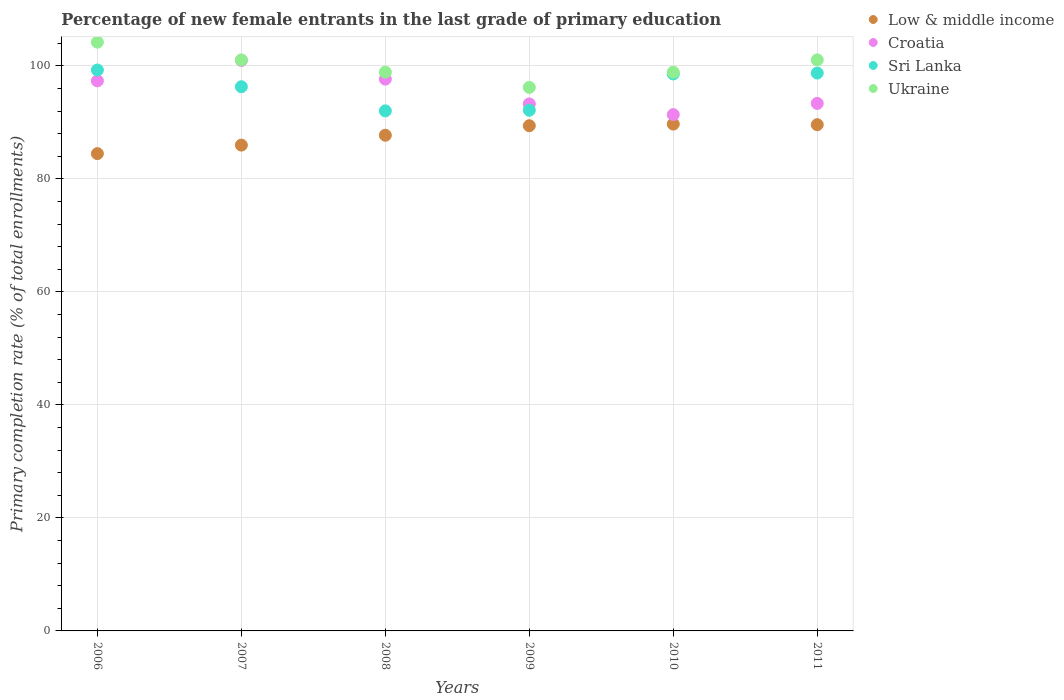Is the number of dotlines equal to the number of legend labels?
Offer a terse response. Yes. What is the percentage of new female entrants in Croatia in 2008?
Your response must be concise. 97.68. Across all years, what is the maximum percentage of new female entrants in Sri Lanka?
Keep it short and to the point. 99.28. Across all years, what is the minimum percentage of new female entrants in Sri Lanka?
Give a very brief answer. 92.05. In which year was the percentage of new female entrants in Ukraine maximum?
Your answer should be compact. 2006. What is the total percentage of new female entrants in Sri Lanka in the graph?
Your response must be concise. 577.14. What is the difference between the percentage of new female entrants in Sri Lanka in 2007 and that in 2008?
Give a very brief answer. 4.27. What is the difference between the percentage of new female entrants in Croatia in 2006 and the percentage of new female entrants in Sri Lanka in 2008?
Provide a short and direct response. 5.32. What is the average percentage of new female entrants in Sri Lanka per year?
Ensure brevity in your answer.  96.19. In the year 2011, what is the difference between the percentage of new female entrants in Ukraine and percentage of new female entrants in Croatia?
Provide a succinct answer. 7.7. What is the ratio of the percentage of new female entrants in Ukraine in 2009 to that in 2010?
Your answer should be compact. 0.97. Is the percentage of new female entrants in Sri Lanka in 2007 less than that in 2011?
Offer a terse response. Yes. What is the difference between the highest and the second highest percentage of new female entrants in Sri Lanka?
Your answer should be very brief. 0.54. What is the difference between the highest and the lowest percentage of new female entrants in Low & middle income?
Your answer should be very brief. 5.23. Is the sum of the percentage of new female entrants in Ukraine in 2009 and 2010 greater than the maximum percentage of new female entrants in Croatia across all years?
Your answer should be very brief. Yes. Is it the case that in every year, the sum of the percentage of new female entrants in Low & middle income and percentage of new female entrants in Ukraine  is greater than the percentage of new female entrants in Croatia?
Your response must be concise. Yes. Does the percentage of new female entrants in Croatia monotonically increase over the years?
Ensure brevity in your answer.  No. Is the percentage of new female entrants in Sri Lanka strictly greater than the percentage of new female entrants in Croatia over the years?
Offer a terse response. No. Is the percentage of new female entrants in Ukraine strictly less than the percentage of new female entrants in Sri Lanka over the years?
Make the answer very short. No. How many dotlines are there?
Give a very brief answer. 4. How many years are there in the graph?
Provide a short and direct response. 6. What is the difference between two consecutive major ticks on the Y-axis?
Provide a succinct answer. 20. Are the values on the major ticks of Y-axis written in scientific E-notation?
Give a very brief answer. No. Where does the legend appear in the graph?
Your answer should be compact. Top right. How many legend labels are there?
Your answer should be compact. 4. What is the title of the graph?
Provide a short and direct response. Percentage of new female entrants in the last grade of primary education. What is the label or title of the X-axis?
Your answer should be very brief. Years. What is the label or title of the Y-axis?
Your response must be concise. Primary completion rate (% of total enrollments). What is the Primary completion rate (% of total enrollments) in Low & middle income in 2006?
Offer a very short reply. 84.48. What is the Primary completion rate (% of total enrollments) of Croatia in 2006?
Offer a terse response. 97.37. What is the Primary completion rate (% of total enrollments) in Sri Lanka in 2006?
Provide a succinct answer. 99.28. What is the Primary completion rate (% of total enrollments) in Ukraine in 2006?
Provide a succinct answer. 104.21. What is the Primary completion rate (% of total enrollments) of Low & middle income in 2007?
Your answer should be compact. 85.99. What is the Primary completion rate (% of total enrollments) in Croatia in 2007?
Ensure brevity in your answer.  100.98. What is the Primary completion rate (% of total enrollments) of Sri Lanka in 2007?
Provide a succinct answer. 96.32. What is the Primary completion rate (% of total enrollments) of Ukraine in 2007?
Your answer should be compact. 101.06. What is the Primary completion rate (% of total enrollments) of Low & middle income in 2008?
Provide a succinct answer. 87.74. What is the Primary completion rate (% of total enrollments) of Croatia in 2008?
Keep it short and to the point. 97.68. What is the Primary completion rate (% of total enrollments) of Sri Lanka in 2008?
Ensure brevity in your answer.  92.05. What is the Primary completion rate (% of total enrollments) of Ukraine in 2008?
Your answer should be very brief. 98.91. What is the Primary completion rate (% of total enrollments) in Low & middle income in 2009?
Your response must be concise. 89.42. What is the Primary completion rate (% of total enrollments) of Croatia in 2009?
Offer a terse response. 93.27. What is the Primary completion rate (% of total enrollments) of Sri Lanka in 2009?
Your answer should be very brief. 92.16. What is the Primary completion rate (% of total enrollments) of Ukraine in 2009?
Give a very brief answer. 96.21. What is the Primary completion rate (% of total enrollments) of Low & middle income in 2010?
Give a very brief answer. 89.71. What is the Primary completion rate (% of total enrollments) in Croatia in 2010?
Give a very brief answer. 91.39. What is the Primary completion rate (% of total enrollments) in Sri Lanka in 2010?
Ensure brevity in your answer.  98.58. What is the Primary completion rate (% of total enrollments) in Ukraine in 2010?
Offer a very short reply. 98.9. What is the Primary completion rate (% of total enrollments) of Low & middle income in 2011?
Offer a terse response. 89.6. What is the Primary completion rate (% of total enrollments) of Croatia in 2011?
Offer a very short reply. 93.37. What is the Primary completion rate (% of total enrollments) in Sri Lanka in 2011?
Provide a succinct answer. 98.74. What is the Primary completion rate (% of total enrollments) in Ukraine in 2011?
Offer a terse response. 101.07. Across all years, what is the maximum Primary completion rate (% of total enrollments) in Low & middle income?
Give a very brief answer. 89.71. Across all years, what is the maximum Primary completion rate (% of total enrollments) in Croatia?
Your answer should be very brief. 100.98. Across all years, what is the maximum Primary completion rate (% of total enrollments) of Sri Lanka?
Make the answer very short. 99.28. Across all years, what is the maximum Primary completion rate (% of total enrollments) of Ukraine?
Provide a succinct answer. 104.21. Across all years, what is the minimum Primary completion rate (% of total enrollments) of Low & middle income?
Your response must be concise. 84.48. Across all years, what is the minimum Primary completion rate (% of total enrollments) in Croatia?
Make the answer very short. 91.39. Across all years, what is the minimum Primary completion rate (% of total enrollments) in Sri Lanka?
Your answer should be very brief. 92.05. Across all years, what is the minimum Primary completion rate (% of total enrollments) in Ukraine?
Offer a terse response. 96.21. What is the total Primary completion rate (% of total enrollments) of Low & middle income in the graph?
Your response must be concise. 526.94. What is the total Primary completion rate (% of total enrollments) of Croatia in the graph?
Give a very brief answer. 574.05. What is the total Primary completion rate (% of total enrollments) of Sri Lanka in the graph?
Offer a terse response. 577.14. What is the total Primary completion rate (% of total enrollments) in Ukraine in the graph?
Your response must be concise. 600.36. What is the difference between the Primary completion rate (% of total enrollments) in Low & middle income in 2006 and that in 2007?
Provide a succinct answer. -1.51. What is the difference between the Primary completion rate (% of total enrollments) of Croatia in 2006 and that in 2007?
Give a very brief answer. -3.61. What is the difference between the Primary completion rate (% of total enrollments) of Sri Lanka in 2006 and that in 2007?
Your answer should be very brief. 2.96. What is the difference between the Primary completion rate (% of total enrollments) in Ukraine in 2006 and that in 2007?
Give a very brief answer. 3.15. What is the difference between the Primary completion rate (% of total enrollments) of Low & middle income in 2006 and that in 2008?
Offer a terse response. -3.26. What is the difference between the Primary completion rate (% of total enrollments) of Croatia in 2006 and that in 2008?
Give a very brief answer. -0.31. What is the difference between the Primary completion rate (% of total enrollments) of Sri Lanka in 2006 and that in 2008?
Your answer should be compact. 7.23. What is the difference between the Primary completion rate (% of total enrollments) of Ukraine in 2006 and that in 2008?
Offer a terse response. 5.31. What is the difference between the Primary completion rate (% of total enrollments) in Low & middle income in 2006 and that in 2009?
Offer a terse response. -4.94. What is the difference between the Primary completion rate (% of total enrollments) of Croatia in 2006 and that in 2009?
Give a very brief answer. 4.09. What is the difference between the Primary completion rate (% of total enrollments) of Sri Lanka in 2006 and that in 2009?
Offer a very short reply. 7.12. What is the difference between the Primary completion rate (% of total enrollments) in Ukraine in 2006 and that in 2009?
Make the answer very short. 8.01. What is the difference between the Primary completion rate (% of total enrollments) in Low & middle income in 2006 and that in 2010?
Your answer should be very brief. -5.23. What is the difference between the Primary completion rate (% of total enrollments) of Croatia in 2006 and that in 2010?
Offer a very short reply. 5.98. What is the difference between the Primary completion rate (% of total enrollments) of Sri Lanka in 2006 and that in 2010?
Your answer should be compact. 0.7. What is the difference between the Primary completion rate (% of total enrollments) in Ukraine in 2006 and that in 2010?
Your answer should be compact. 5.32. What is the difference between the Primary completion rate (% of total enrollments) in Low & middle income in 2006 and that in 2011?
Your response must be concise. -5.12. What is the difference between the Primary completion rate (% of total enrollments) in Croatia in 2006 and that in 2011?
Your answer should be very brief. 4. What is the difference between the Primary completion rate (% of total enrollments) in Sri Lanka in 2006 and that in 2011?
Your response must be concise. 0.54. What is the difference between the Primary completion rate (% of total enrollments) of Ukraine in 2006 and that in 2011?
Keep it short and to the point. 3.14. What is the difference between the Primary completion rate (% of total enrollments) of Low & middle income in 2007 and that in 2008?
Your answer should be compact. -1.75. What is the difference between the Primary completion rate (% of total enrollments) of Croatia in 2007 and that in 2008?
Make the answer very short. 3.3. What is the difference between the Primary completion rate (% of total enrollments) in Sri Lanka in 2007 and that in 2008?
Keep it short and to the point. 4.27. What is the difference between the Primary completion rate (% of total enrollments) in Ukraine in 2007 and that in 2008?
Give a very brief answer. 2.16. What is the difference between the Primary completion rate (% of total enrollments) in Low & middle income in 2007 and that in 2009?
Ensure brevity in your answer.  -3.43. What is the difference between the Primary completion rate (% of total enrollments) of Croatia in 2007 and that in 2009?
Give a very brief answer. 7.7. What is the difference between the Primary completion rate (% of total enrollments) in Sri Lanka in 2007 and that in 2009?
Make the answer very short. 4.16. What is the difference between the Primary completion rate (% of total enrollments) in Ukraine in 2007 and that in 2009?
Your response must be concise. 4.86. What is the difference between the Primary completion rate (% of total enrollments) of Low & middle income in 2007 and that in 2010?
Offer a terse response. -3.72. What is the difference between the Primary completion rate (% of total enrollments) of Croatia in 2007 and that in 2010?
Offer a terse response. 9.59. What is the difference between the Primary completion rate (% of total enrollments) of Sri Lanka in 2007 and that in 2010?
Your response must be concise. -2.26. What is the difference between the Primary completion rate (% of total enrollments) of Ukraine in 2007 and that in 2010?
Offer a terse response. 2.17. What is the difference between the Primary completion rate (% of total enrollments) of Low & middle income in 2007 and that in 2011?
Your answer should be compact. -3.61. What is the difference between the Primary completion rate (% of total enrollments) of Croatia in 2007 and that in 2011?
Keep it short and to the point. 7.61. What is the difference between the Primary completion rate (% of total enrollments) of Sri Lanka in 2007 and that in 2011?
Give a very brief answer. -2.42. What is the difference between the Primary completion rate (% of total enrollments) in Ukraine in 2007 and that in 2011?
Provide a succinct answer. -0.01. What is the difference between the Primary completion rate (% of total enrollments) in Low & middle income in 2008 and that in 2009?
Offer a very short reply. -1.69. What is the difference between the Primary completion rate (% of total enrollments) in Croatia in 2008 and that in 2009?
Offer a terse response. 4.4. What is the difference between the Primary completion rate (% of total enrollments) of Sri Lanka in 2008 and that in 2009?
Your answer should be compact. -0.12. What is the difference between the Primary completion rate (% of total enrollments) of Ukraine in 2008 and that in 2009?
Offer a terse response. 2.7. What is the difference between the Primary completion rate (% of total enrollments) in Low & middle income in 2008 and that in 2010?
Offer a terse response. -1.97. What is the difference between the Primary completion rate (% of total enrollments) of Croatia in 2008 and that in 2010?
Offer a terse response. 6.29. What is the difference between the Primary completion rate (% of total enrollments) in Sri Lanka in 2008 and that in 2010?
Provide a succinct answer. -6.53. What is the difference between the Primary completion rate (% of total enrollments) of Ukraine in 2008 and that in 2010?
Offer a terse response. 0.01. What is the difference between the Primary completion rate (% of total enrollments) in Low & middle income in 2008 and that in 2011?
Offer a terse response. -1.87. What is the difference between the Primary completion rate (% of total enrollments) of Croatia in 2008 and that in 2011?
Provide a succinct answer. 4.31. What is the difference between the Primary completion rate (% of total enrollments) of Sri Lanka in 2008 and that in 2011?
Offer a terse response. -6.69. What is the difference between the Primary completion rate (% of total enrollments) of Ukraine in 2008 and that in 2011?
Ensure brevity in your answer.  -2.17. What is the difference between the Primary completion rate (% of total enrollments) in Low & middle income in 2009 and that in 2010?
Provide a succinct answer. -0.29. What is the difference between the Primary completion rate (% of total enrollments) in Croatia in 2009 and that in 2010?
Provide a short and direct response. 1.89. What is the difference between the Primary completion rate (% of total enrollments) in Sri Lanka in 2009 and that in 2010?
Offer a very short reply. -6.42. What is the difference between the Primary completion rate (% of total enrollments) of Ukraine in 2009 and that in 2010?
Offer a very short reply. -2.69. What is the difference between the Primary completion rate (% of total enrollments) in Low & middle income in 2009 and that in 2011?
Give a very brief answer. -0.18. What is the difference between the Primary completion rate (% of total enrollments) of Croatia in 2009 and that in 2011?
Ensure brevity in your answer.  -0.1. What is the difference between the Primary completion rate (% of total enrollments) in Sri Lanka in 2009 and that in 2011?
Provide a succinct answer. -6.58. What is the difference between the Primary completion rate (% of total enrollments) of Ukraine in 2009 and that in 2011?
Offer a terse response. -4.87. What is the difference between the Primary completion rate (% of total enrollments) of Low & middle income in 2010 and that in 2011?
Offer a very short reply. 0.11. What is the difference between the Primary completion rate (% of total enrollments) of Croatia in 2010 and that in 2011?
Provide a succinct answer. -1.98. What is the difference between the Primary completion rate (% of total enrollments) of Sri Lanka in 2010 and that in 2011?
Your response must be concise. -0.16. What is the difference between the Primary completion rate (% of total enrollments) in Ukraine in 2010 and that in 2011?
Your answer should be very brief. -2.17. What is the difference between the Primary completion rate (% of total enrollments) of Low & middle income in 2006 and the Primary completion rate (% of total enrollments) of Croatia in 2007?
Keep it short and to the point. -16.5. What is the difference between the Primary completion rate (% of total enrollments) in Low & middle income in 2006 and the Primary completion rate (% of total enrollments) in Sri Lanka in 2007?
Make the answer very short. -11.84. What is the difference between the Primary completion rate (% of total enrollments) of Low & middle income in 2006 and the Primary completion rate (% of total enrollments) of Ukraine in 2007?
Keep it short and to the point. -16.58. What is the difference between the Primary completion rate (% of total enrollments) in Croatia in 2006 and the Primary completion rate (% of total enrollments) in Sri Lanka in 2007?
Ensure brevity in your answer.  1.04. What is the difference between the Primary completion rate (% of total enrollments) in Croatia in 2006 and the Primary completion rate (% of total enrollments) in Ukraine in 2007?
Your answer should be very brief. -3.7. What is the difference between the Primary completion rate (% of total enrollments) of Sri Lanka in 2006 and the Primary completion rate (% of total enrollments) of Ukraine in 2007?
Your response must be concise. -1.78. What is the difference between the Primary completion rate (% of total enrollments) in Low & middle income in 2006 and the Primary completion rate (% of total enrollments) in Croatia in 2008?
Offer a terse response. -13.2. What is the difference between the Primary completion rate (% of total enrollments) of Low & middle income in 2006 and the Primary completion rate (% of total enrollments) of Sri Lanka in 2008?
Offer a very short reply. -7.57. What is the difference between the Primary completion rate (% of total enrollments) of Low & middle income in 2006 and the Primary completion rate (% of total enrollments) of Ukraine in 2008?
Provide a succinct answer. -14.43. What is the difference between the Primary completion rate (% of total enrollments) of Croatia in 2006 and the Primary completion rate (% of total enrollments) of Sri Lanka in 2008?
Keep it short and to the point. 5.32. What is the difference between the Primary completion rate (% of total enrollments) in Croatia in 2006 and the Primary completion rate (% of total enrollments) in Ukraine in 2008?
Provide a short and direct response. -1.54. What is the difference between the Primary completion rate (% of total enrollments) in Sri Lanka in 2006 and the Primary completion rate (% of total enrollments) in Ukraine in 2008?
Provide a short and direct response. 0.38. What is the difference between the Primary completion rate (% of total enrollments) of Low & middle income in 2006 and the Primary completion rate (% of total enrollments) of Croatia in 2009?
Give a very brief answer. -8.79. What is the difference between the Primary completion rate (% of total enrollments) of Low & middle income in 2006 and the Primary completion rate (% of total enrollments) of Sri Lanka in 2009?
Provide a succinct answer. -7.68. What is the difference between the Primary completion rate (% of total enrollments) in Low & middle income in 2006 and the Primary completion rate (% of total enrollments) in Ukraine in 2009?
Your answer should be compact. -11.73. What is the difference between the Primary completion rate (% of total enrollments) in Croatia in 2006 and the Primary completion rate (% of total enrollments) in Sri Lanka in 2009?
Your response must be concise. 5.2. What is the difference between the Primary completion rate (% of total enrollments) in Croatia in 2006 and the Primary completion rate (% of total enrollments) in Ukraine in 2009?
Make the answer very short. 1.16. What is the difference between the Primary completion rate (% of total enrollments) of Sri Lanka in 2006 and the Primary completion rate (% of total enrollments) of Ukraine in 2009?
Offer a very short reply. 3.08. What is the difference between the Primary completion rate (% of total enrollments) in Low & middle income in 2006 and the Primary completion rate (% of total enrollments) in Croatia in 2010?
Make the answer very short. -6.91. What is the difference between the Primary completion rate (% of total enrollments) of Low & middle income in 2006 and the Primary completion rate (% of total enrollments) of Sri Lanka in 2010?
Provide a succinct answer. -14.1. What is the difference between the Primary completion rate (% of total enrollments) in Low & middle income in 2006 and the Primary completion rate (% of total enrollments) in Ukraine in 2010?
Keep it short and to the point. -14.42. What is the difference between the Primary completion rate (% of total enrollments) of Croatia in 2006 and the Primary completion rate (% of total enrollments) of Sri Lanka in 2010?
Your response must be concise. -1.22. What is the difference between the Primary completion rate (% of total enrollments) of Croatia in 2006 and the Primary completion rate (% of total enrollments) of Ukraine in 2010?
Provide a short and direct response. -1.53. What is the difference between the Primary completion rate (% of total enrollments) of Sri Lanka in 2006 and the Primary completion rate (% of total enrollments) of Ukraine in 2010?
Your answer should be compact. 0.39. What is the difference between the Primary completion rate (% of total enrollments) of Low & middle income in 2006 and the Primary completion rate (% of total enrollments) of Croatia in 2011?
Offer a very short reply. -8.89. What is the difference between the Primary completion rate (% of total enrollments) of Low & middle income in 2006 and the Primary completion rate (% of total enrollments) of Sri Lanka in 2011?
Your answer should be very brief. -14.26. What is the difference between the Primary completion rate (% of total enrollments) in Low & middle income in 2006 and the Primary completion rate (% of total enrollments) in Ukraine in 2011?
Offer a terse response. -16.59. What is the difference between the Primary completion rate (% of total enrollments) in Croatia in 2006 and the Primary completion rate (% of total enrollments) in Sri Lanka in 2011?
Your response must be concise. -1.38. What is the difference between the Primary completion rate (% of total enrollments) in Croatia in 2006 and the Primary completion rate (% of total enrollments) in Ukraine in 2011?
Ensure brevity in your answer.  -3.71. What is the difference between the Primary completion rate (% of total enrollments) in Sri Lanka in 2006 and the Primary completion rate (% of total enrollments) in Ukraine in 2011?
Offer a terse response. -1.79. What is the difference between the Primary completion rate (% of total enrollments) of Low & middle income in 2007 and the Primary completion rate (% of total enrollments) of Croatia in 2008?
Make the answer very short. -11.69. What is the difference between the Primary completion rate (% of total enrollments) of Low & middle income in 2007 and the Primary completion rate (% of total enrollments) of Sri Lanka in 2008?
Make the answer very short. -6.06. What is the difference between the Primary completion rate (% of total enrollments) in Low & middle income in 2007 and the Primary completion rate (% of total enrollments) in Ukraine in 2008?
Your answer should be very brief. -12.92. What is the difference between the Primary completion rate (% of total enrollments) in Croatia in 2007 and the Primary completion rate (% of total enrollments) in Sri Lanka in 2008?
Offer a very short reply. 8.93. What is the difference between the Primary completion rate (% of total enrollments) of Croatia in 2007 and the Primary completion rate (% of total enrollments) of Ukraine in 2008?
Offer a terse response. 2.07. What is the difference between the Primary completion rate (% of total enrollments) in Sri Lanka in 2007 and the Primary completion rate (% of total enrollments) in Ukraine in 2008?
Make the answer very short. -2.58. What is the difference between the Primary completion rate (% of total enrollments) of Low & middle income in 2007 and the Primary completion rate (% of total enrollments) of Croatia in 2009?
Your response must be concise. -7.28. What is the difference between the Primary completion rate (% of total enrollments) in Low & middle income in 2007 and the Primary completion rate (% of total enrollments) in Sri Lanka in 2009?
Provide a succinct answer. -6.17. What is the difference between the Primary completion rate (% of total enrollments) in Low & middle income in 2007 and the Primary completion rate (% of total enrollments) in Ukraine in 2009?
Provide a succinct answer. -10.22. What is the difference between the Primary completion rate (% of total enrollments) of Croatia in 2007 and the Primary completion rate (% of total enrollments) of Sri Lanka in 2009?
Make the answer very short. 8.81. What is the difference between the Primary completion rate (% of total enrollments) in Croatia in 2007 and the Primary completion rate (% of total enrollments) in Ukraine in 2009?
Offer a very short reply. 4.77. What is the difference between the Primary completion rate (% of total enrollments) of Sri Lanka in 2007 and the Primary completion rate (% of total enrollments) of Ukraine in 2009?
Offer a terse response. 0.12. What is the difference between the Primary completion rate (% of total enrollments) of Low & middle income in 2007 and the Primary completion rate (% of total enrollments) of Croatia in 2010?
Keep it short and to the point. -5.4. What is the difference between the Primary completion rate (% of total enrollments) in Low & middle income in 2007 and the Primary completion rate (% of total enrollments) in Sri Lanka in 2010?
Offer a terse response. -12.59. What is the difference between the Primary completion rate (% of total enrollments) of Low & middle income in 2007 and the Primary completion rate (% of total enrollments) of Ukraine in 2010?
Your response must be concise. -12.91. What is the difference between the Primary completion rate (% of total enrollments) in Croatia in 2007 and the Primary completion rate (% of total enrollments) in Sri Lanka in 2010?
Give a very brief answer. 2.39. What is the difference between the Primary completion rate (% of total enrollments) in Croatia in 2007 and the Primary completion rate (% of total enrollments) in Ukraine in 2010?
Provide a succinct answer. 2.08. What is the difference between the Primary completion rate (% of total enrollments) in Sri Lanka in 2007 and the Primary completion rate (% of total enrollments) in Ukraine in 2010?
Make the answer very short. -2.57. What is the difference between the Primary completion rate (% of total enrollments) in Low & middle income in 2007 and the Primary completion rate (% of total enrollments) in Croatia in 2011?
Provide a short and direct response. -7.38. What is the difference between the Primary completion rate (% of total enrollments) in Low & middle income in 2007 and the Primary completion rate (% of total enrollments) in Sri Lanka in 2011?
Provide a succinct answer. -12.75. What is the difference between the Primary completion rate (% of total enrollments) in Low & middle income in 2007 and the Primary completion rate (% of total enrollments) in Ukraine in 2011?
Your answer should be very brief. -15.08. What is the difference between the Primary completion rate (% of total enrollments) in Croatia in 2007 and the Primary completion rate (% of total enrollments) in Sri Lanka in 2011?
Give a very brief answer. 2.23. What is the difference between the Primary completion rate (% of total enrollments) of Croatia in 2007 and the Primary completion rate (% of total enrollments) of Ukraine in 2011?
Offer a terse response. -0.1. What is the difference between the Primary completion rate (% of total enrollments) of Sri Lanka in 2007 and the Primary completion rate (% of total enrollments) of Ukraine in 2011?
Offer a very short reply. -4.75. What is the difference between the Primary completion rate (% of total enrollments) in Low & middle income in 2008 and the Primary completion rate (% of total enrollments) in Croatia in 2009?
Your response must be concise. -5.54. What is the difference between the Primary completion rate (% of total enrollments) in Low & middle income in 2008 and the Primary completion rate (% of total enrollments) in Sri Lanka in 2009?
Ensure brevity in your answer.  -4.43. What is the difference between the Primary completion rate (% of total enrollments) in Low & middle income in 2008 and the Primary completion rate (% of total enrollments) in Ukraine in 2009?
Ensure brevity in your answer.  -8.47. What is the difference between the Primary completion rate (% of total enrollments) of Croatia in 2008 and the Primary completion rate (% of total enrollments) of Sri Lanka in 2009?
Your answer should be very brief. 5.51. What is the difference between the Primary completion rate (% of total enrollments) of Croatia in 2008 and the Primary completion rate (% of total enrollments) of Ukraine in 2009?
Keep it short and to the point. 1.47. What is the difference between the Primary completion rate (% of total enrollments) in Sri Lanka in 2008 and the Primary completion rate (% of total enrollments) in Ukraine in 2009?
Offer a very short reply. -4.16. What is the difference between the Primary completion rate (% of total enrollments) of Low & middle income in 2008 and the Primary completion rate (% of total enrollments) of Croatia in 2010?
Provide a short and direct response. -3.65. What is the difference between the Primary completion rate (% of total enrollments) in Low & middle income in 2008 and the Primary completion rate (% of total enrollments) in Sri Lanka in 2010?
Your response must be concise. -10.85. What is the difference between the Primary completion rate (% of total enrollments) in Low & middle income in 2008 and the Primary completion rate (% of total enrollments) in Ukraine in 2010?
Your answer should be very brief. -11.16. What is the difference between the Primary completion rate (% of total enrollments) in Croatia in 2008 and the Primary completion rate (% of total enrollments) in Sri Lanka in 2010?
Provide a short and direct response. -0.91. What is the difference between the Primary completion rate (% of total enrollments) in Croatia in 2008 and the Primary completion rate (% of total enrollments) in Ukraine in 2010?
Offer a very short reply. -1.22. What is the difference between the Primary completion rate (% of total enrollments) in Sri Lanka in 2008 and the Primary completion rate (% of total enrollments) in Ukraine in 2010?
Ensure brevity in your answer.  -6.85. What is the difference between the Primary completion rate (% of total enrollments) of Low & middle income in 2008 and the Primary completion rate (% of total enrollments) of Croatia in 2011?
Your answer should be very brief. -5.63. What is the difference between the Primary completion rate (% of total enrollments) in Low & middle income in 2008 and the Primary completion rate (% of total enrollments) in Sri Lanka in 2011?
Ensure brevity in your answer.  -11.01. What is the difference between the Primary completion rate (% of total enrollments) in Low & middle income in 2008 and the Primary completion rate (% of total enrollments) in Ukraine in 2011?
Your response must be concise. -13.34. What is the difference between the Primary completion rate (% of total enrollments) in Croatia in 2008 and the Primary completion rate (% of total enrollments) in Sri Lanka in 2011?
Your answer should be compact. -1.07. What is the difference between the Primary completion rate (% of total enrollments) in Croatia in 2008 and the Primary completion rate (% of total enrollments) in Ukraine in 2011?
Your response must be concise. -3.4. What is the difference between the Primary completion rate (% of total enrollments) of Sri Lanka in 2008 and the Primary completion rate (% of total enrollments) of Ukraine in 2011?
Offer a very short reply. -9.02. What is the difference between the Primary completion rate (% of total enrollments) in Low & middle income in 2009 and the Primary completion rate (% of total enrollments) in Croatia in 2010?
Make the answer very short. -1.96. What is the difference between the Primary completion rate (% of total enrollments) in Low & middle income in 2009 and the Primary completion rate (% of total enrollments) in Sri Lanka in 2010?
Offer a very short reply. -9.16. What is the difference between the Primary completion rate (% of total enrollments) in Low & middle income in 2009 and the Primary completion rate (% of total enrollments) in Ukraine in 2010?
Offer a terse response. -9.47. What is the difference between the Primary completion rate (% of total enrollments) of Croatia in 2009 and the Primary completion rate (% of total enrollments) of Sri Lanka in 2010?
Give a very brief answer. -5.31. What is the difference between the Primary completion rate (% of total enrollments) of Croatia in 2009 and the Primary completion rate (% of total enrollments) of Ukraine in 2010?
Provide a succinct answer. -5.62. What is the difference between the Primary completion rate (% of total enrollments) of Sri Lanka in 2009 and the Primary completion rate (% of total enrollments) of Ukraine in 2010?
Keep it short and to the point. -6.73. What is the difference between the Primary completion rate (% of total enrollments) of Low & middle income in 2009 and the Primary completion rate (% of total enrollments) of Croatia in 2011?
Offer a very short reply. -3.94. What is the difference between the Primary completion rate (% of total enrollments) of Low & middle income in 2009 and the Primary completion rate (% of total enrollments) of Sri Lanka in 2011?
Make the answer very short. -9.32. What is the difference between the Primary completion rate (% of total enrollments) in Low & middle income in 2009 and the Primary completion rate (% of total enrollments) in Ukraine in 2011?
Ensure brevity in your answer.  -11.65. What is the difference between the Primary completion rate (% of total enrollments) in Croatia in 2009 and the Primary completion rate (% of total enrollments) in Sri Lanka in 2011?
Ensure brevity in your answer.  -5.47. What is the difference between the Primary completion rate (% of total enrollments) in Croatia in 2009 and the Primary completion rate (% of total enrollments) in Ukraine in 2011?
Offer a terse response. -7.8. What is the difference between the Primary completion rate (% of total enrollments) of Sri Lanka in 2009 and the Primary completion rate (% of total enrollments) of Ukraine in 2011?
Offer a terse response. -8.91. What is the difference between the Primary completion rate (% of total enrollments) of Low & middle income in 2010 and the Primary completion rate (% of total enrollments) of Croatia in 2011?
Offer a very short reply. -3.66. What is the difference between the Primary completion rate (% of total enrollments) of Low & middle income in 2010 and the Primary completion rate (% of total enrollments) of Sri Lanka in 2011?
Ensure brevity in your answer.  -9.03. What is the difference between the Primary completion rate (% of total enrollments) in Low & middle income in 2010 and the Primary completion rate (% of total enrollments) in Ukraine in 2011?
Offer a very short reply. -11.36. What is the difference between the Primary completion rate (% of total enrollments) in Croatia in 2010 and the Primary completion rate (% of total enrollments) in Sri Lanka in 2011?
Make the answer very short. -7.36. What is the difference between the Primary completion rate (% of total enrollments) in Croatia in 2010 and the Primary completion rate (% of total enrollments) in Ukraine in 2011?
Your response must be concise. -9.69. What is the difference between the Primary completion rate (% of total enrollments) in Sri Lanka in 2010 and the Primary completion rate (% of total enrollments) in Ukraine in 2011?
Provide a short and direct response. -2.49. What is the average Primary completion rate (% of total enrollments) in Low & middle income per year?
Offer a terse response. 87.82. What is the average Primary completion rate (% of total enrollments) of Croatia per year?
Offer a terse response. 95.67. What is the average Primary completion rate (% of total enrollments) in Sri Lanka per year?
Ensure brevity in your answer.  96.19. What is the average Primary completion rate (% of total enrollments) of Ukraine per year?
Provide a succinct answer. 100.06. In the year 2006, what is the difference between the Primary completion rate (% of total enrollments) in Low & middle income and Primary completion rate (% of total enrollments) in Croatia?
Your answer should be very brief. -12.89. In the year 2006, what is the difference between the Primary completion rate (% of total enrollments) in Low & middle income and Primary completion rate (% of total enrollments) in Sri Lanka?
Offer a terse response. -14.8. In the year 2006, what is the difference between the Primary completion rate (% of total enrollments) of Low & middle income and Primary completion rate (% of total enrollments) of Ukraine?
Provide a short and direct response. -19.73. In the year 2006, what is the difference between the Primary completion rate (% of total enrollments) of Croatia and Primary completion rate (% of total enrollments) of Sri Lanka?
Offer a very short reply. -1.92. In the year 2006, what is the difference between the Primary completion rate (% of total enrollments) of Croatia and Primary completion rate (% of total enrollments) of Ukraine?
Keep it short and to the point. -6.85. In the year 2006, what is the difference between the Primary completion rate (% of total enrollments) of Sri Lanka and Primary completion rate (% of total enrollments) of Ukraine?
Provide a short and direct response. -4.93. In the year 2007, what is the difference between the Primary completion rate (% of total enrollments) of Low & middle income and Primary completion rate (% of total enrollments) of Croatia?
Your answer should be compact. -14.99. In the year 2007, what is the difference between the Primary completion rate (% of total enrollments) of Low & middle income and Primary completion rate (% of total enrollments) of Sri Lanka?
Keep it short and to the point. -10.33. In the year 2007, what is the difference between the Primary completion rate (% of total enrollments) in Low & middle income and Primary completion rate (% of total enrollments) in Ukraine?
Keep it short and to the point. -15.08. In the year 2007, what is the difference between the Primary completion rate (% of total enrollments) of Croatia and Primary completion rate (% of total enrollments) of Sri Lanka?
Keep it short and to the point. 4.65. In the year 2007, what is the difference between the Primary completion rate (% of total enrollments) in Croatia and Primary completion rate (% of total enrollments) in Ukraine?
Ensure brevity in your answer.  -0.09. In the year 2007, what is the difference between the Primary completion rate (% of total enrollments) of Sri Lanka and Primary completion rate (% of total enrollments) of Ukraine?
Your answer should be very brief. -4.74. In the year 2008, what is the difference between the Primary completion rate (% of total enrollments) in Low & middle income and Primary completion rate (% of total enrollments) in Croatia?
Give a very brief answer. -9.94. In the year 2008, what is the difference between the Primary completion rate (% of total enrollments) in Low & middle income and Primary completion rate (% of total enrollments) in Sri Lanka?
Offer a terse response. -4.31. In the year 2008, what is the difference between the Primary completion rate (% of total enrollments) of Low & middle income and Primary completion rate (% of total enrollments) of Ukraine?
Keep it short and to the point. -11.17. In the year 2008, what is the difference between the Primary completion rate (% of total enrollments) of Croatia and Primary completion rate (% of total enrollments) of Sri Lanka?
Your response must be concise. 5.63. In the year 2008, what is the difference between the Primary completion rate (% of total enrollments) in Croatia and Primary completion rate (% of total enrollments) in Ukraine?
Offer a terse response. -1.23. In the year 2008, what is the difference between the Primary completion rate (% of total enrollments) in Sri Lanka and Primary completion rate (% of total enrollments) in Ukraine?
Ensure brevity in your answer.  -6.86. In the year 2009, what is the difference between the Primary completion rate (% of total enrollments) of Low & middle income and Primary completion rate (% of total enrollments) of Croatia?
Keep it short and to the point. -3.85. In the year 2009, what is the difference between the Primary completion rate (% of total enrollments) in Low & middle income and Primary completion rate (% of total enrollments) in Sri Lanka?
Give a very brief answer. -2.74. In the year 2009, what is the difference between the Primary completion rate (% of total enrollments) in Low & middle income and Primary completion rate (% of total enrollments) in Ukraine?
Your answer should be compact. -6.78. In the year 2009, what is the difference between the Primary completion rate (% of total enrollments) in Croatia and Primary completion rate (% of total enrollments) in Sri Lanka?
Your response must be concise. 1.11. In the year 2009, what is the difference between the Primary completion rate (% of total enrollments) of Croatia and Primary completion rate (% of total enrollments) of Ukraine?
Make the answer very short. -2.93. In the year 2009, what is the difference between the Primary completion rate (% of total enrollments) in Sri Lanka and Primary completion rate (% of total enrollments) in Ukraine?
Offer a terse response. -4.04. In the year 2010, what is the difference between the Primary completion rate (% of total enrollments) in Low & middle income and Primary completion rate (% of total enrollments) in Croatia?
Make the answer very short. -1.68. In the year 2010, what is the difference between the Primary completion rate (% of total enrollments) of Low & middle income and Primary completion rate (% of total enrollments) of Sri Lanka?
Your answer should be compact. -8.87. In the year 2010, what is the difference between the Primary completion rate (% of total enrollments) in Low & middle income and Primary completion rate (% of total enrollments) in Ukraine?
Offer a terse response. -9.19. In the year 2010, what is the difference between the Primary completion rate (% of total enrollments) of Croatia and Primary completion rate (% of total enrollments) of Sri Lanka?
Your answer should be compact. -7.2. In the year 2010, what is the difference between the Primary completion rate (% of total enrollments) of Croatia and Primary completion rate (% of total enrollments) of Ukraine?
Your answer should be very brief. -7.51. In the year 2010, what is the difference between the Primary completion rate (% of total enrollments) in Sri Lanka and Primary completion rate (% of total enrollments) in Ukraine?
Your answer should be compact. -0.32. In the year 2011, what is the difference between the Primary completion rate (% of total enrollments) in Low & middle income and Primary completion rate (% of total enrollments) in Croatia?
Your answer should be compact. -3.76. In the year 2011, what is the difference between the Primary completion rate (% of total enrollments) of Low & middle income and Primary completion rate (% of total enrollments) of Sri Lanka?
Keep it short and to the point. -9.14. In the year 2011, what is the difference between the Primary completion rate (% of total enrollments) in Low & middle income and Primary completion rate (% of total enrollments) in Ukraine?
Your response must be concise. -11.47. In the year 2011, what is the difference between the Primary completion rate (% of total enrollments) of Croatia and Primary completion rate (% of total enrollments) of Sri Lanka?
Provide a short and direct response. -5.37. In the year 2011, what is the difference between the Primary completion rate (% of total enrollments) in Croatia and Primary completion rate (% of total enrollments) in Ukraine?
Give a very brief answer. -7.7. In the year 2011, what is the difference between the Primary completion rate (% of total enrollments) in Sri Lanka and Primary completion rate (% of total enrollments) in Ukraine?
Your answer should be compact. -2.33. What is the ratio of the Primary completion rate (% of total enrollments) in Low & middle income in 2006 to that in 2007?
Give a very brief answer. 0.98. What is the ratio of the Primary completion rate (% of total enrollments) in Sri Lanka in 2006 to that in 2007?
Your answer should be compact. 1.03. What is the ratio of the Primary completion rate (% of total enrollments) of Ukraine in 2006 to that in 2007?
Give a very brief answer. 1.03. What is the ratio of the Primary completion rate (% of total enrollments) of Low & middle income in 2006 to that in 2008?
Provide a succinct answer. 0.96. What is the ratio of the Primary completion rate (% of total enrollments) of Sri Lanka in 2006 to that in 2008?
Keep it short and to the point. 1.08. What is the ratio of the Primary completion rate (% of total enrollments) in Ukraine in 2006 to that in 2008?
Provide a short and direct response. 1.05. What is the ratio of the Primary completion rate (% of total enrollments) in Low & middle income in 2006 to that in 2009?
Make the answer very short. 0.94. What is the ratio of the Primary completion rate (% of total enrollments) in Croatia in 2006 to that in 2009?
Your answer should be compact. 1.04. What is the ratio of the Primary completion rate (% of total enrollments) in Sri Lanka in 2006 to that in 2009?
Your answer should be compact. 1.08. What is the ratio of the Primary completion rate (% of total enrollments) in Ukraine in 2006 to that in 2009?
Your response must be concise. 1.08. What is the ratio of the Primary completion rate (% of total enrollments) of Low & middle income in 2006 to that in 2010?
Ensure brevity in your answer.  0.94. What is the ratio of the Primary completion rate (% of total enrollments) in Croatia in 2006 to that in 2010?
Keep it short and to the point. 1.07. What is the ratio of the Primary completion rate (% of total enrollments) of Sri Lanka in 2006 to that in 2010?
Offer a terse response. 1.01. What is the ratio of the Primary completion rate (% of total enrollments) of Ukraine in 2006 to that in 2010?
Your answer should be very brief. 1.05. What is the ratio of the Primary completion rate (% of total enrollments) of Low & middle income in 2006 to that in 2011?
Provide a succinct answer. 0.94. What is the ratio of the Primary completion rate (% of total enrollments) of Croatia in 2006 to that in 2011?
Offer a very short reply. 1.04. What is the ratio of the Primary completion rate (% of total enrollments) of Sri Lanka in 2006 to that in 2011?
Keep it short and to the point. 1.01. What is the ratio of the Primary completion rate (% of total enrollments) of Ukraine in 2006 to that in 2011?
Give a very brief answer. 1.03. What is the ratio of the Primary completion rate (% of total enrollments) in Low & middle income in 2007 to that in 2008?
Your response must be concise. 0.98. What is the ratio of the Primary completion rate (% of total enrollments) in Croatia in 2007 to that in 2008?
Provide a short and direct response. 1.03. What is the ratio of the Primary completion rate (% of total enrollments) of Sri Lanka in 2007 to that in 2008?
Your answer should be compact. 1.05. What is the ratio of the Primary completion rate (% of total enrollments) in Ukraine in 2007 to that in 2008?
Keep it short and to the point. 1.02. What is the ratio of the Primary completion rate (% of total enrollments) of Low & middle income in 2007 to that in 2009?
Offer a very short reply. 0.96. What is the ratio of the Primary completion rate (% of total enrollments) of Croatia in 2007 to that in 2009?
Offer a very short reply. 1.08. What is the ratio of the Primary completion rate (% of total enrollments) of Sri Lanka in 2007 to that in 2009?
Your answer should be compact. 1.05. What is the ratio of the Primary completion rate (% of total enrollments) in Ukraine in 2007 to that in 2009?
Make the answer very short. 1.05. What is the ratio of the Primary completion rate (% of total enrollments) of Low & middle income in 2007 to that in 2010?
Keep it short and to the point. 0.96. What is the ratio of the Primary completion rate (% of total enrollments) of Croatia in 2007 to that in 2010?
Keep it short and to the point. 1.1. What is the ratio of the Primary completion rate (% of total enrollments) of Sri Lanka in 2007 to that in 2010?
Make the answer very short. 0.98. What is the ratio of the Primary completion rate (% of total enrollments) in Ukraine in 2007 to that in 2010?
Make the answer very short. 1.02. What is the ratio of the Primary completion rate (% of total enrollments) of Low & middle income in 2007 to that in 2011?
Your answer should be compact. 0.96. What is the ratio of the Primary completion rate (% of total enrollments) in Croatia in 2007 to that in 2011?
Ensure brevity in your answer.  1.08. What is the ratio of the Primary completion rate (% of total enrollments) in Sri Lanka in 2007 to that in 2011?
Offer a terse response. 0.98. What is the ratio of the Primary completion rate (% of total enrollments) in Low & middle income in 2008 to that in 2009?
Keep it short and to the point. 0.98. What is the ratio of the Primary completion rate (% of total enrollments) in Croatia in 2008 to that in 2009?
Your response must be concise. 1.05. What is the ratio of the Primary completion rate (% of total enrollments) of Ukraine in 2008 to that in 2009?
Offer a terse response. 1.03. What is the ratio of the Primary completion rate (% of total enrollments) in Croatia in 2008 to that in 2010?
Keep it short and to the point. 1.07. What is the ratio of the Primary completion rate (% of total enrollments) in Sri Lanka in 2008 to that in 2010?
Give a very brief answer. 0.93. What is the ratio of the Primary completion rate (% of total enrollments) in Ukraine in 2008 to that in 2010?
Make the answer very short. 1. What is the ratio of the Primary completion rate (% of total enrollments) in Low & middle income in 2008 to that in 2011?
Your response must be concise. 0.98. What is the ratio of the Primary completion rate (% of total enrollments) in Croatia in 2008 to that in 2011?
Your response must be concise. 1.05. What is the ratio of the Primary completion rate (% of total enrollments) in Sri Lanka in 2008 to that in 2011?
Give a very brief answer. 0.93. What is the ratio of the Primary completion rate (% of total enrollments) in Ukraine in 2008 to that in 2011?
Your answer should be very brief. 0.98. What is the ratio of the Primary completion rate (% of total enrollments) of Low & middle income in 2009 to that in 2010?
Your response must be concise. 1. What is the ratio of the Primary completion rate (% of total enrollments) in Croatia in 2009 to that in 2010?
Give a very brief answer. 1.02. What is the ratio of the Primary completion rate (% of total enrollments) of Sri Lanka in 2009 to that in 2010?
Ensure brevity in your answer.  0.93. What is the ratio of the Primary completion rate (% of total enrollments) in Ukraine in 2009 to that in 2010?
Provide a succinct answer. 0.97. What is the ratio of the Primary completion rate (% of total enrollments) of Low & middle income in 2009 to that in 2011?
Your answer should be very brief. 1. What is the ratio of the Primary completion rate (% of total enrollments) of Sri Lanka in 2009 to that in 2011?
Provide a succinct answer. 0.93. What is the ratio of the Primary completion rate (% of total enrollments) in Ukraine in 2009 to that in 2011?
Keep it short and to the point. 0.95. What is the ratio of the Primary completion rate (% of total enrollments) of Low & middle income in 2010 to that in 2011?
Provide a short and direct response. 1. What is the ratio of the Primary completion rate (% of total enrollments) in Croatia in 2010 to that in 2011?
Your answer should be compact. 0.98. What is the ratio of the Primary completion rate (% of total enrollments) in Sri Lanka in 2010 to that in 2011?
Your answer should be compact. 1. What is the ratio of the Primary completion rate (% of total enrollments) in Ukraine in 2010 to that in 2011?
Offer a terse response. 0.98. What is the difference between the highest and the second highest Primary completion rate (% of total enrollments) in Low & middle income?
Your response must be concise. 0.11. What is the difference between the highest and the second highest Primary completion rate (% of total enrollments) in Croatia?
Offer a terse response. 3.3. What is the difference between the highest and the second highest Primary completion rate (% of total enrollments) of Sri Lanka?
Your answer should be compact. 0.54. What is the difference between the highest and the second highest Primary completion rate (% of total enrollments) in Ukraine?
Your response must be concise. 3.14. What is the difference between the highest and the lowest Primary completion rate (% of total enrollments) in Low & middle income?
Provide a succinct answer. 5.23. What is the difference between the highest and the lowest Primary completion rate (% of total enrollments) in Croatia?
Provide a succinct answer. 9.59. What is the difference between the highest and the lowest Primary completion rate (% of total enrollments) of Sri Lanka?
Make the answer very short. 7.23. What is the difference between the highest and the lowest Primary completion rate (% of total enrollments) in Ukraine?
Ensure brevity in your answer.  8.01. 